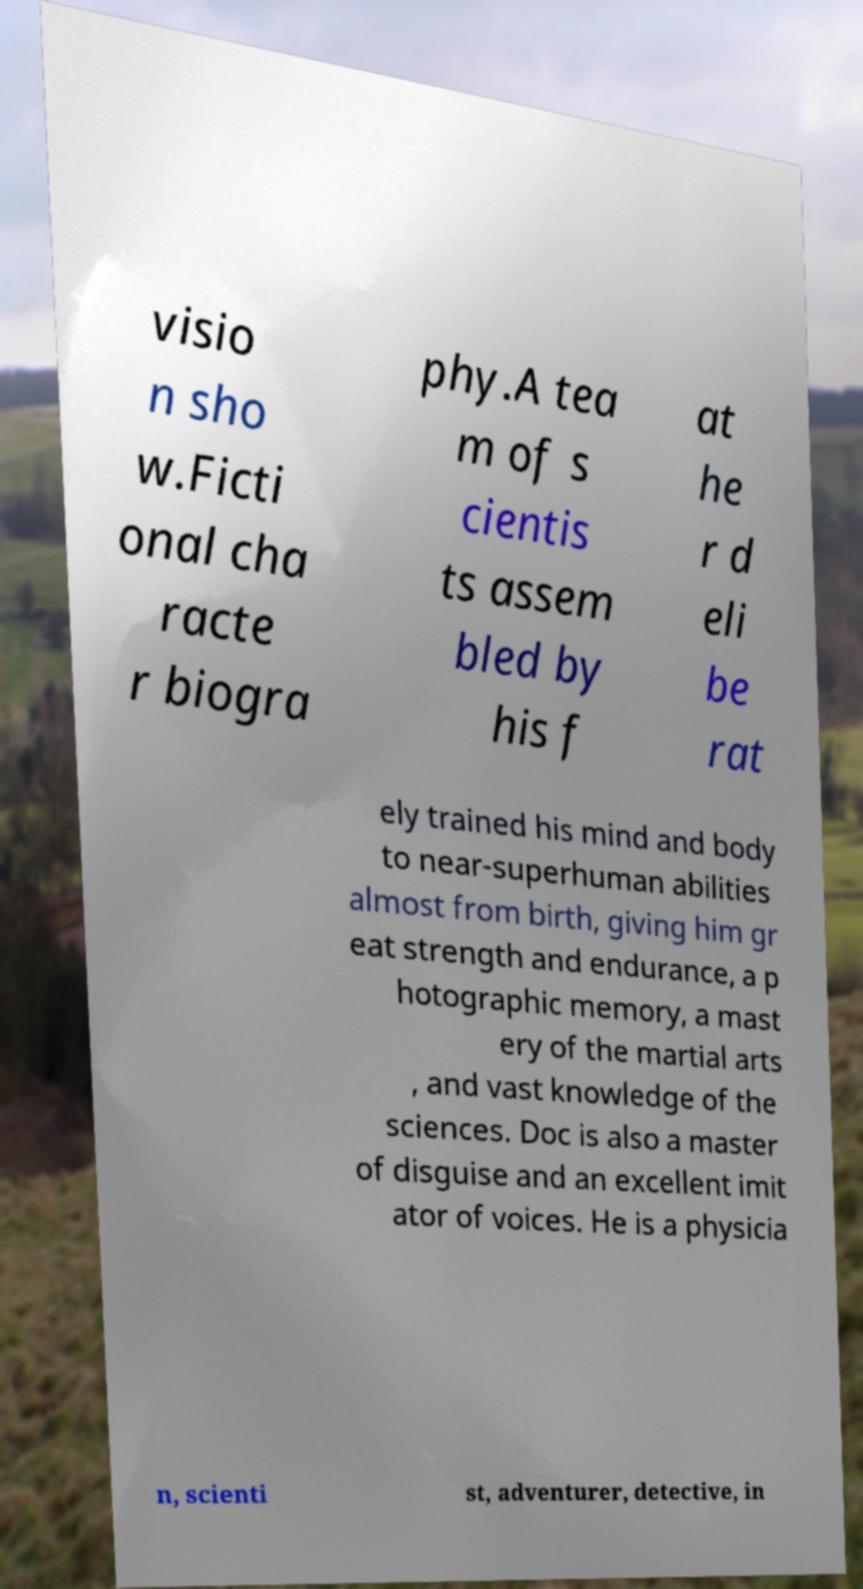Can you accurately transcribe the text from the provided image for me? visio n sho w.Ficti onal cha racte r biogra phy.A tea m of s cientis ts assem bled by his f at he r d eli be rat ely trained his mind and body to near-superhuman abilities almost from birth, giving him gr eat strength and endurance, a p hotographic memory, a mast ery of the martial arts , and vast knowledge of the sciences. Doc is also a master of disguise and an excellent imit ator of voices. He is a physicia n, scienti st, adventurer, detective, in 